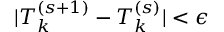<formula> <loc_0><loc_0><loc_500><loc_500>| T _ { k } ^ { ( s + 1 ) } - T _ { k } ^ { ( s ) } | < \epsilon</formula> 